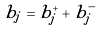Convert formula to latex. <formula><loc_0><loc_0><loc_500><loc_500>b _ { j } = b ^ { + } _ { j } + b ^ { - } _ { j }</formula> 